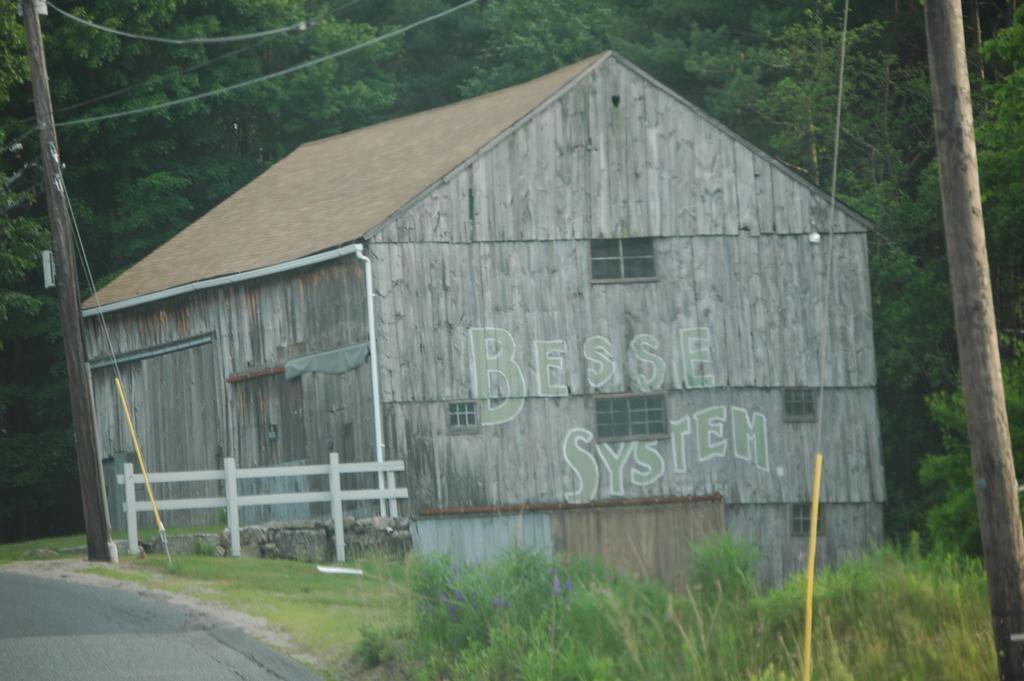Could you give a brief overview of what you see in this image? In this picture we can see the road, fence, poles, house with windows, plants, wires and in the background we can see trees. 